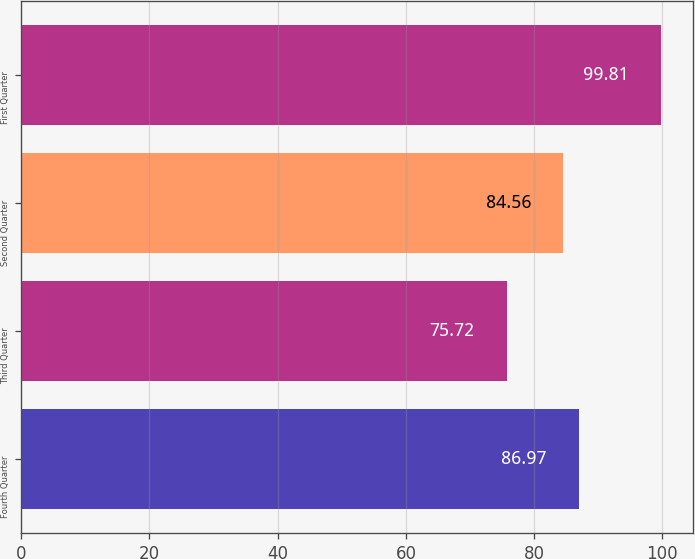Convert chart. <chart><loc_0><loc_0><loc_500><loc_500><bar_chart><fcel>Fourth Quarter<fcel>Third Quarter<fcel>Second Quarter<fcel>First Quarter<nl><fcel>86.97<fcel>75.72<fcel>84.56<fcel>99.81<nl></chart> 